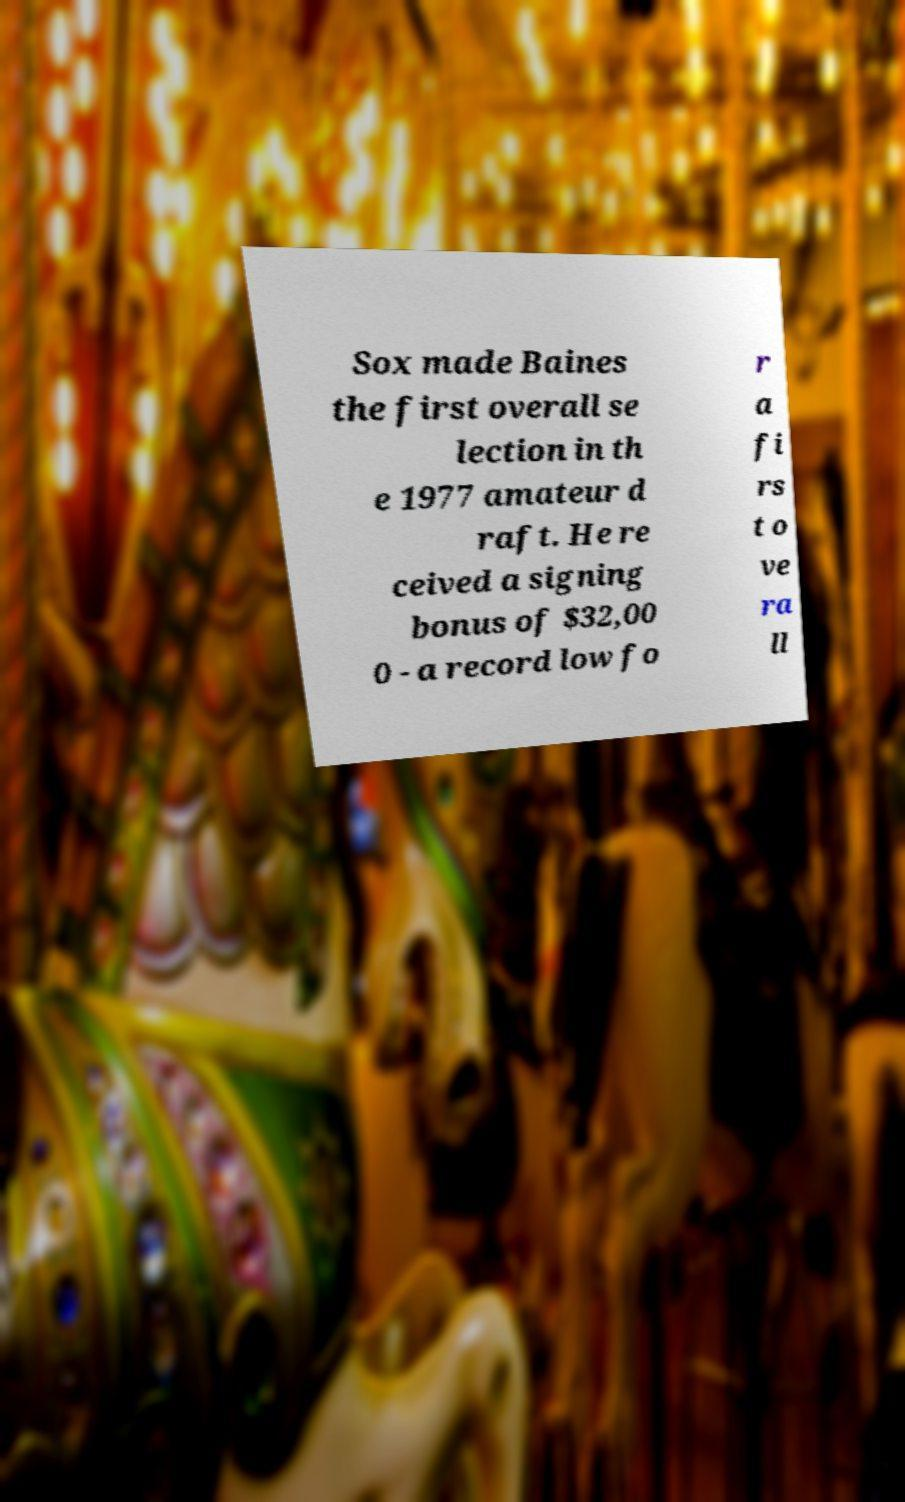Please read and relay the text visible in this image. What does it say? Sox made Baines the first overall se lection in th e 1977 amateur d raft. He re ceived a signing bonus of $32,00 0 - a record low fo r a fi rs t o ve ra ll 